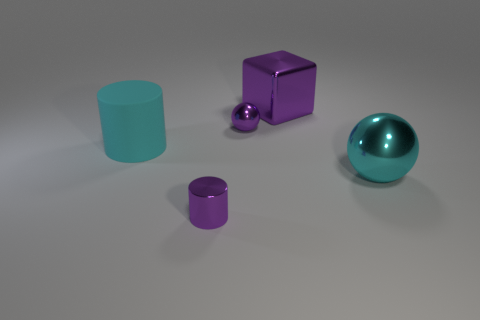What is the object that is on the right side of the tiny sphere and on the left side of the large cyan shiny sphere made of?
Your answer should be very brief. Metal. There is a big object that is both in front of the big metallic cube and on the left side of the big cyan sphere; what is its color?
Your answer should be compact. Cyan. There is a tiny metal thing that is behind the large cyan object that is on the left side of the thing in front of the large metallic sphere; what shape is it?
Offer a terse response. Sphere. The tiny object that is the same shape as the big cyan shiny object is what color?
Ensure brevity in your answer.  Purple. What color is the small thing that is to the left of the small thing behind the tiny shiny cylinder?
Your answer should be compact. Purple. What number of purple cylinders have the same material as the cyan cylinder?
Give a very brief answer. 0. There is a metallic object on the right side of the block; how many small things are in front of it?
Your answer should be very brief. 1. Are there any purple shiny cylinders left of the cyan metal thing?
Offer a terse response. Yes. Does the tiny metal object behind the large sphere have the same shape as the large cyan matte thing?
Provide a succinct answer. No. There is another big thing that is the same color as the rubber object; what is its material?
Keep it short and to the point. Metal. 